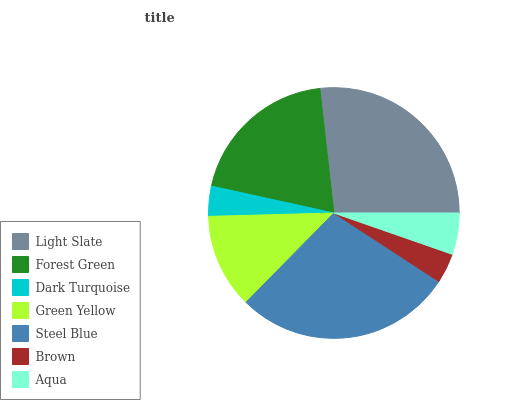Is Brown the minimum?
Answer yes or no. Yes. Is Steel Blue the maximum?
Answer yes or no. Yes. Is Forest Green the minimum?
Answer yes or no. No. Is Forest Green the maximum?
Answer yes or no. No. Is Light Slate greater than Forest Green?
Answer yes or no. Yes. Is Forest Green less than Light Slate?
Answer yes or no. Yes. Is Forest Green greater than Light Slate?
Answer yes or no. No. Is Light Slate less than Forest Green?
Answer yes or no. No. Is Green Yellow the high median?
Answer yes or no. Yes. Is Green Yellow the low median?
Answer yes or no. Yes. Is Steel Blue the high median?
Answer yes or no. No. Is Dark Turquoise the low median?
Answer yes or no. No. 